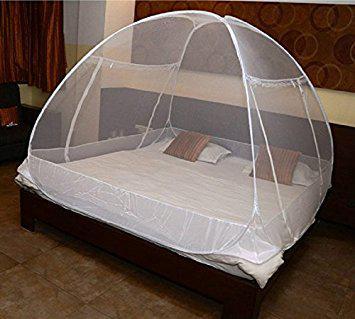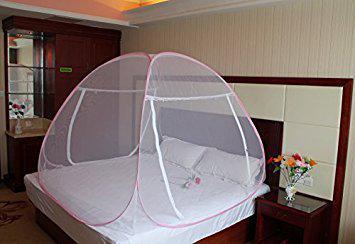The first image is the image on the left, the second image is the image on the right. Assess this claim about the two images: "there are two brown pillows in the image on the left". Correct or not? Answer yes or no. Yes. The first image is the image on the left, the second image is the image on the right. Given the left and right images, does the statement "In at least one image, a green and blue case sits in front of a bed canopy." hold true? Answer yes or no. No. 